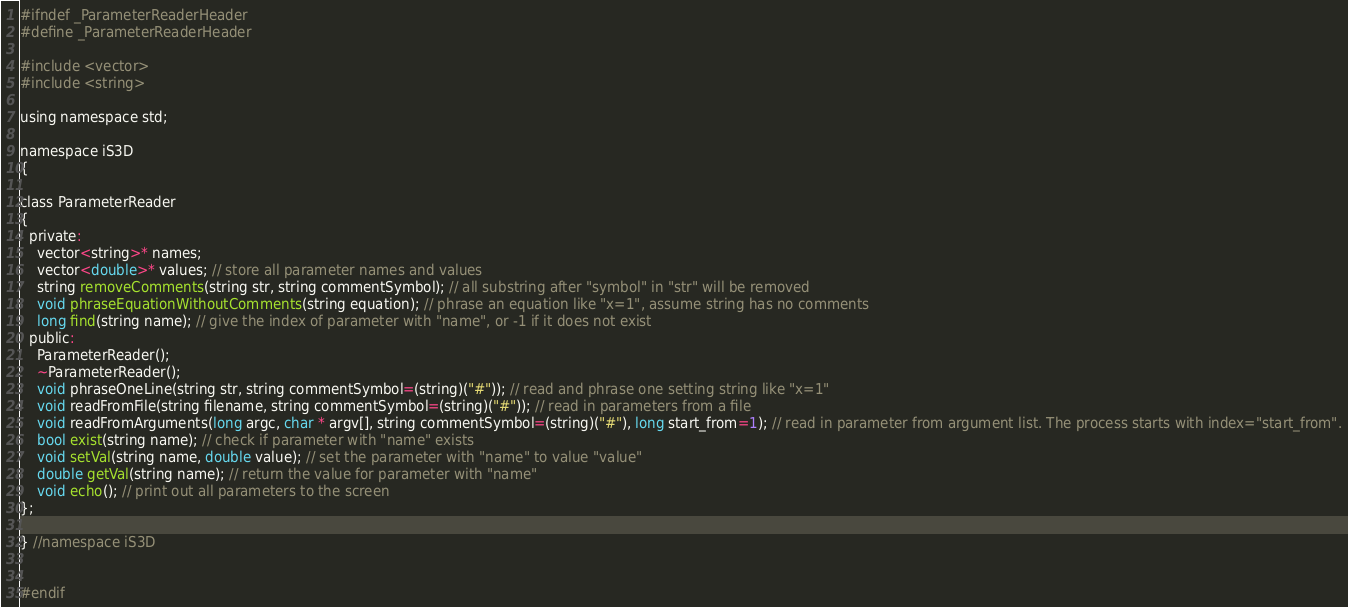<code> <loc_0><loc_0><loc_500><loc_500><_Cuda_>
#ifndef _ParameterReaderHeader
#define _ParameterReaderHeader

#include <vector>
#include <string>

using namespace std;

namespace iS3D
{

class ParameterReader
{
  private:
    vector<string>* names;
    vector<double>* values; // store all parameter names and values
    string removeComments(string str, string commentSymbol); // all substring after "symbol" in "str" will be removed
    void phraseEquationWithoutComments(string equation); // phrase an equation like "x=1", assume string has no comments
    long find(string name); // give the index of parameter with "name", or -1 if it does not exist
  public:
    ParameterReader();
    ~ParameterReader();
    void phraseOneLine(string str, string commentSymbol=(string)("#")); // read and phrase one setting string like "x=1"
    void readFromFile(string filename, string commentSymbol=(string)("#")); // read in parameters from a file
    void readFromArguments(long argc, char * argv[], string commentSymbol=(string)("#"), long start_from=1); // read in parameter from argument list. The process starts with index="start_from".
    bool exist(string name); // check if parameter with "name" exists
    void setVal(string name, double value); // set the parameter with "name" to value "value"
    double getVal(string name); // return the value for parameter with "name"
    void echo(); // print out all parameters to the screen
};

} //namespace iS3D


#endif
</code> 